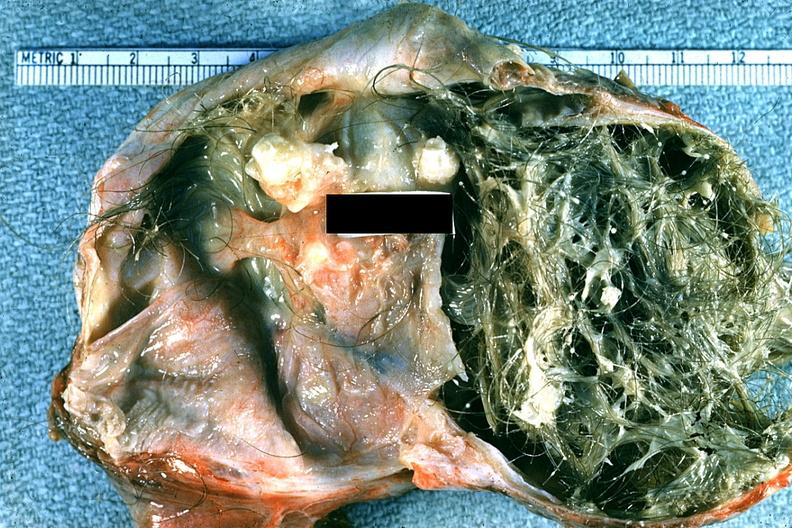s mucoepidermoid carcinoma present?
Answer the question using a single word or phrase. No 